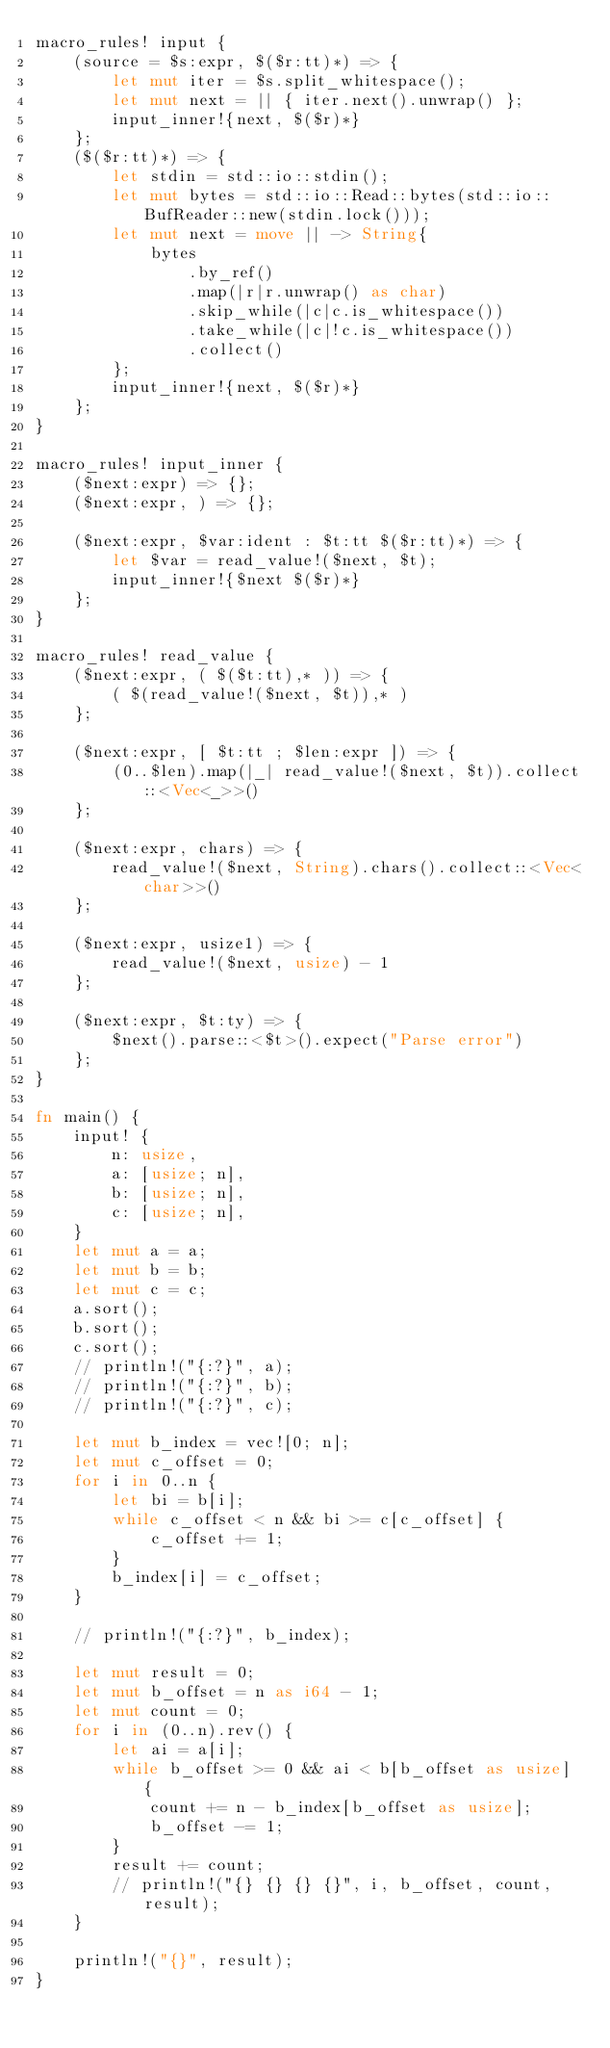<code> <loc_0><loc_0><loc_500><loc_500><_Rust_>macro_rules! input {
    (source = $s:expr, $($r:tt)*) => {
        let mut iter = $s.split_whitespace();
        let mut next = || { iter.next().unwrap() };
        input_inner!{next, $($r)*}
    };
    ($($r:tt)*) => {
        let stdin = std::io::stdin();
        let mut bytes = std::io::Read::bytes(std::io::BufReader::new(stdin.lock()));
        let mut next = move || -> String{
            bytes
                .by_ref()
                .map(|r|r.unwrap() as char)
                .skip_while(|c|c.is_whitespace())
                .take_while(|c|!c.is_whitespace())
                .collect()
        };
        input_inner!{next, $($r)*}
    };
}

macro_rules! input_inner {
    ($next:expr) => {};
    ($next:expr, ) => {};

    ($next:expr, $var:ident : $t:tt $($r:tt)*) => {
        let $var = read_value!($next, $t);
        input_inner!{$next $($r)*}
    };
}

macro_rules! read_value {
    ($next:expr, ( $($t:tt),* )) => {
        ( $(read_value!($next, $t)),* )
    };

    ($next:expr, [ $t:tt ; $len:expr ]) => {
        (0..$len).map(|_| read_value!($next, $t)).collect::<Vec<_>>()
    };

    ($next:expr, chars) => {
        read_value!($next, String).chars().collect::<Vec<char>>()
    };

    ($next:expr, usize1) => {
        read_value!($next, usize) - 1
    };

    ($next:expr, $t:ty) => {
        $next().parse::<$t>().expect("Parse error")
    };
}

fn main() {
    input! {
        n: usize,
        a: [usize; n],
        b: [usize; n],
        c: [usize; n],
    }
    let mut a = a;
    let mut b = b;
    let mut c = c;
    a.sort();
    b.sort();
    c.sort();
    // println!("{:?}", a);
    // println!("{:?}", b);
    // println!("{:?}", c);

    let mut b_index = vec![0; n];
    let mut c_offset = 0;
    for i in 0..n {
        let bi = b[i];
        while c_offset < n && bi >= c[c_offset] {
            c_offset += 1;
        }
        b_index[i] = c_offset;
    }

    // println!("{:?}", b_index);

    let mut result = 0;
    let mut b_offset = n as i64 - 1;
    let mut count = 0;
    for i in (0..n).rev() {
        let ai = a[i];
        while b_offset >= 0 && ai < b[b_offset as usize] {
            count += n - b_index[b_offset as usize];
            b_offset -= 1;
        }
        result += count;
        // println!("{} {} {} {}", i, b_offset, count, result);
    }

    println!("{}", result);
}
</code> 